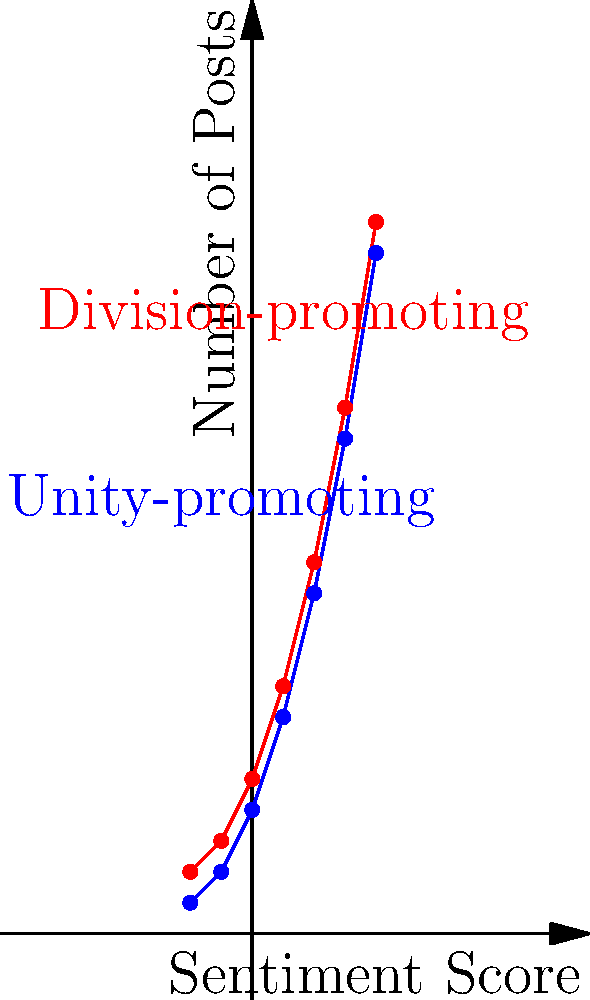In the context of clustering social media posts based on sentiment towards unity and division, examine the graph showing the distribution of posts. The blue line represents unity-promoting posts, while the red line represents division-promoting posts. If we were to apply k-means clustering with $k=2$ to this data, what would be the most likely outcome in terms of cluster centers? To answer this question, let's analyze the graph step-by-step:

1. Observe the two lines: blue (unity-promoting) and red (division-promoting).
2. Note that both lines follow a similar trend, increasing from left to right.
3. The key difference is that the red line (division-promoting) is consistently higher than the blue line (unity-promoting).
4. In k-means clustering with $k=2$, we aim to find two cluster centers that minimize the within-cluster sum of squares.
5. Given the clear separation between the two lines, the algorithm would likely identify two distinct clusters.
6. The cluster centers would be positioned to best represent each line:
   a. One center would be closer to the blue line (lower values)
   b. The other center would be closer to the red line (higher values)
7. The exact position of these centers would be somewhere along the respective lines, likely near the middle of each line to minimize overall distance to all points.

This clustering would effectively separate the unity-promoting and division-promoting posts based on their sentiment scores and frequencies.
Answer: Two centers: one near the blue line (unity-promoting) and one near the red line (division-promoting). 